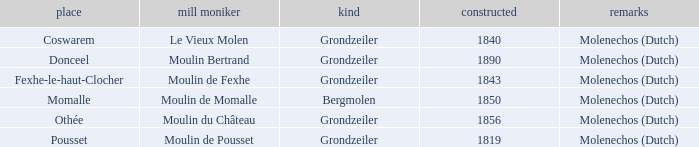What is the Location of the Moulin Bertrand Mill? Donceel. 